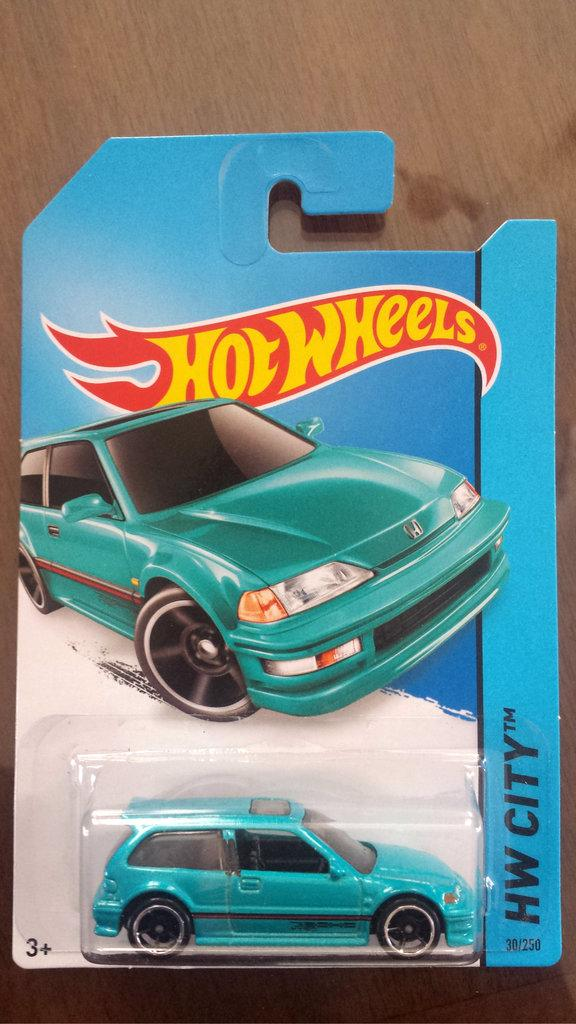What type of toy can be seen in the image? There is a toy vehicle in the image. What else is present in the image besides the toy vehicle? There is a card with text in the image. What can be seen in the background of the image? There is a wooden surface in the background of the image. What type of attack is being planned on the wooden surface in the image? There is no indication of any attack or planning in the image; it simply features a toy vehicle, a card with text, and a wooden surface in the background. 